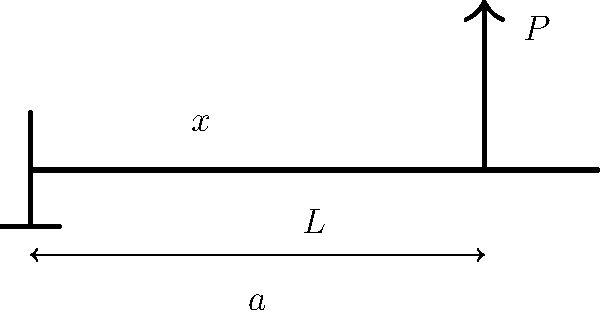A cantilever beam of length $L$ is subjected to a point load $P$ at a distance $a$ from the fixed end. Determine the expression for the bending moment $M(x)$ at any point $x$ along the beam's length. To find the expression for the bending moment $M(x)$ at any point $x$ along the beam's length, we'll follow these steps:

1. Understand the problem:
   - The beam is fixed at one end (left) and free at the other (right).
   - A point load $P$ is applied at distance $a$ from the fixed end.
   - We need to find $M(x)$ for any point $x$ along the beam.

2. Consider the equilibrium of the beam:
   - The reaction force at the fixed end will be equal to $P$ (upward).
   - The reaction moment at the fixed end will balance the moment caused by $P$.

3. Calculate the reaction moment $M_R$ at the fixed end:
   $M_R = P \cdot a$

4. Determine the bending moment $M(x)$ for different regions:

   a) For $0 \leq x \leq a$:
      $M(x) = M_R - P \cdot x = P(a - x)$

   b) For $a < x \leq L$:
      $M(x) = 0$ (no bending moment beyond the point of load application)

5. Combine the expressions into a piecewise function:

   $$M(x) = \begin{cases}
   P(a - x) & \text{for } 0 \leq x \leq a \\
   0 & \text{for } a < x \leq L
   \end{cases}$$

This expression describes the bending moment at any point $x$ along the cantilever beam.
Answer: $$M(x) = \begin{cases}
P(a - x) & \text{for } 0 \leq x \leq a \\
0 & \text{for } a < x \leq L
\end{cases}$$ 